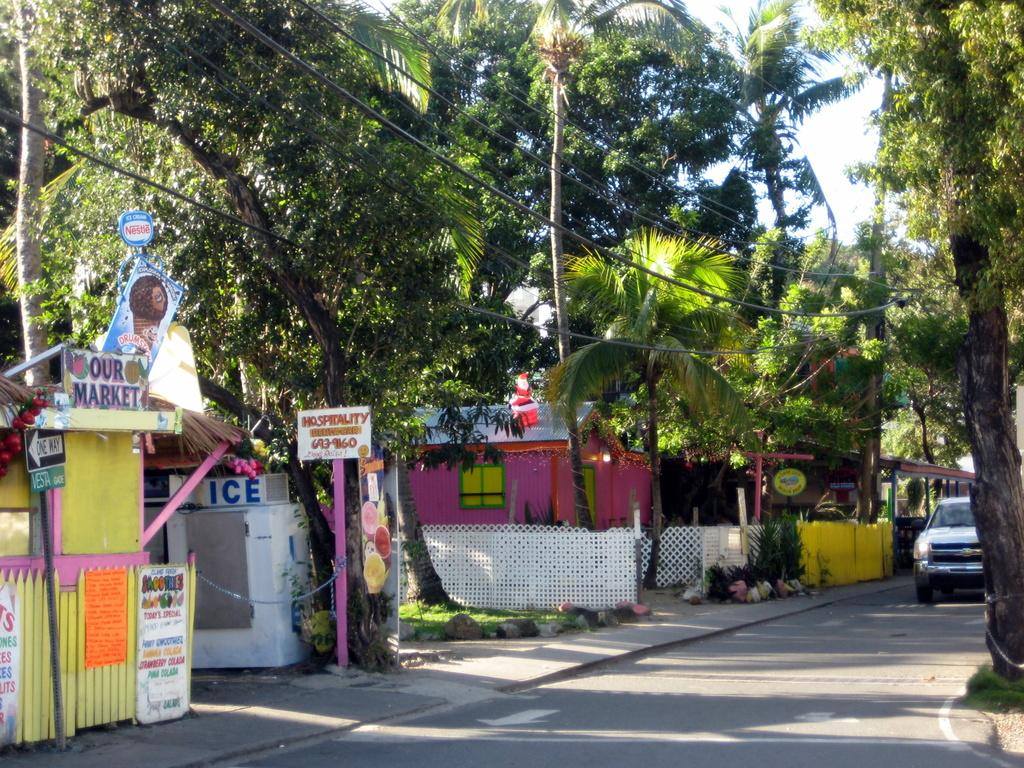What type of structures can be seen in the image? There are sign boards and houses in the image. What natural elements are present in the image? There are trees in the image. What man-made structures can be seen in the image? Cables are visible in the image. What mode of transportation is present in the image? There is a car on the road in the image. How many cent stems can be seen in the image? There is no reference to cent stems in the image; they are not present. What type of fork can be seen in the image? There is no fork present in the image. 